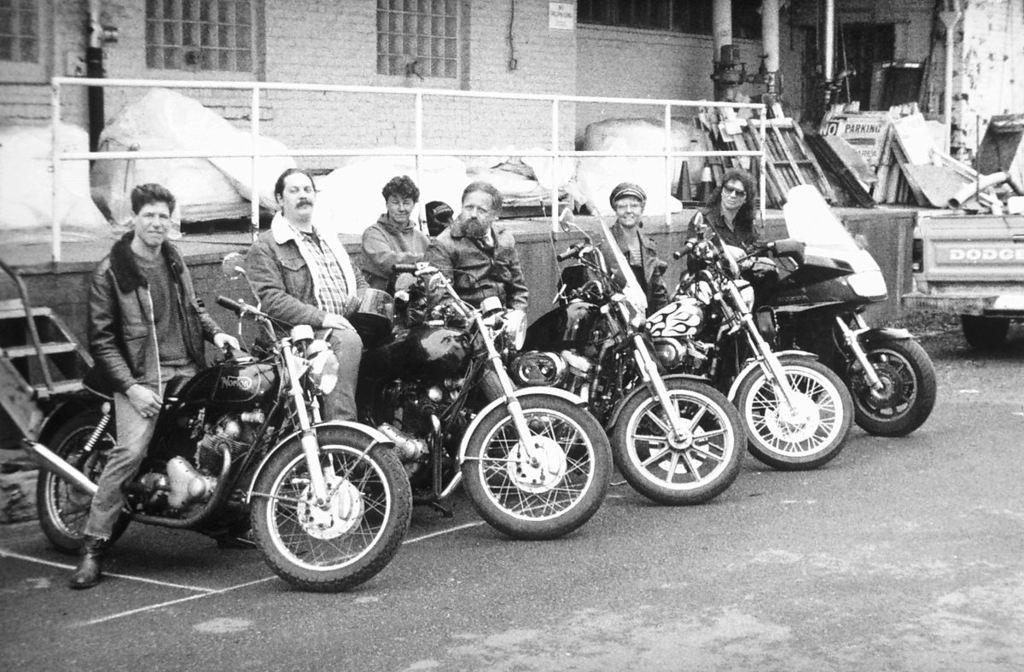How many people are in the image? There are people in the image. What are the people doing in the image? The people are sitting on a bike. What type of individuals might the people in the image be? The people appear to be bikers. Where is the bike located in the image? The bike is on a road. Can you tell me how many strangers are present in the image? There is no mention of strangers in the image, so it is not possible to determine their presence or number. What type of wheel is visible on the bike in the image? The image does not show a close-up view of the bike's wheels, so it is not possible to describe the type of wheel. 